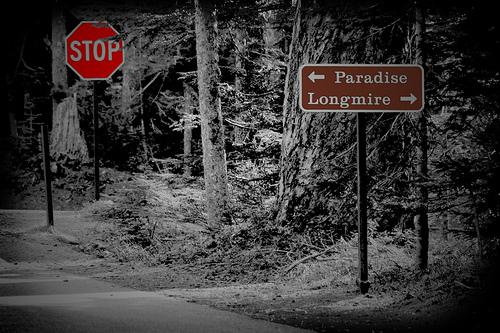Question: what color is the stop sign?
Choices:
A. Green.
B. White.
C. Blue.
D. Red.
Answer with the letter. Answer: D Question: what does the red sign say?
Choices:
A. Hello.
B. Goodbye.
C. Stop.
D. Welcome.
Answer with the letter. Answer: C Question: what direction is Longmire?
Choices:
A. Left.
B. North.
C. Right.
D. South.
Answer with the letter. Answer: C Question: where is are the arrows?
Choices:
A. On the ground.
B. On the highway.
C. On the tree.
D. On the brown sign.
Answer with the letter. Answer: D Question: what direction is Paradise?
Choices:
A. Left.
B. Right.
C. South.
D. East.
Answer with the letter. Answer: A 